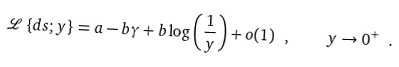Convert formula to latex. <formula><loc_0><loc_0><loc_500><loc_500>\mathcal { L } \left \{ d s ; y \right \} = a - b \gamma + b \log \left ( \frac { 1 } { y } \right ) + o ( 1 ) \ , \quad y \rightarrow 0 ^ { + } \ .</formula> 